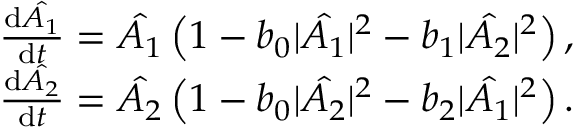Convert formula to latex. <formula><loc_0><loc_0><loc_500><loc_500>\begin{array} { r l } & { \frac { d \hat { A _ { 1 } } } { d t } = \hat { A _ { 1 } } \left ( 1 - b _ { 0 } | \hat { A _ { 1 } } | ^ { 2 } - b _ { 1 } | \hat { A _ { 2 } } | ^ { 2 } \right ) , } \\ & { \frac { d \hat { A _ { 2 } } } { d t } = \hat { A _ { 2 } } \left ( 1 - b _ { 0 } | \hat { A _ { 2 } } | ^ { 2 } - b _ { 2 } | \hat { A _ { 1 } } | ^ { 2 } \right ) . } \end{array}</formula> 